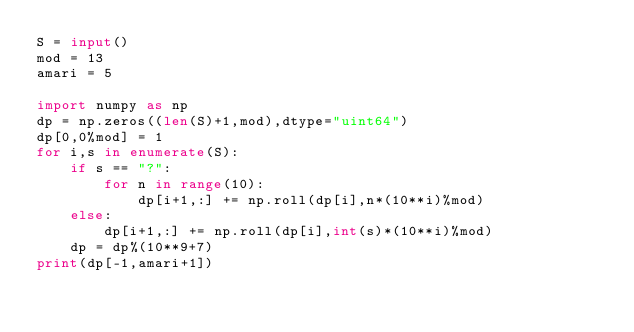<code> <loc_0><loc_0><loc_500><loc_500><_Python_>S = input()
mod = 13
amari = 5

import numpy as np
dp = np.zeros((len(S)+1,mod),dtype="uint64")
dp[0,0%mod] = 1
for i,s in enumerate(S):
    if s == "?":
        for n in range(10):
            dp[i+1,:] += np.roll(dp[i],n*(10**i)%mod)
    else:
        dp[i+1,:] += np.roll(dp[i],int(s)*(10**i)%mod)
    dp = dp%(10**9+7)
print(dp[-1,amari+1])</code> 